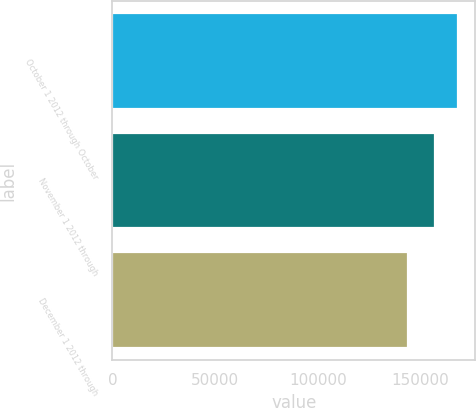Convert chart. <chart><loc_0><loc_0><loc_500><loc_500><bar_chart><fcel>October 1 2012 through October<fcel>November 1 2012 through<fcel>December 1 2012 through<nl><fcel>168339<fcel>156932<fcel>144192<nl></chart> 